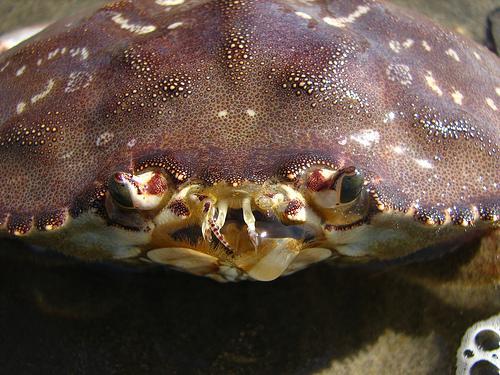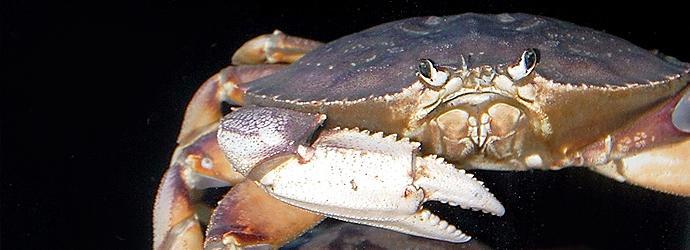The first image is the image on the left, the second image is the image on the right. Analyze the images presented: Is the assertion "Each image includes a crab with a purplish shell looking toward the camera." valid? Answer yes or no. Yes. The first image is the image on the left, the second image is the image on the right. Analyze the images presented: Is the assertion "In at least one image there are red colored cooked crabs showing meat ready to be eaten." valid? Answer yes or no. No. 